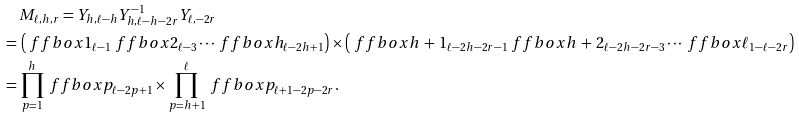<formula> <loc_0><loc_0><loc_500><loc_500>& M _ { \ell , h , r } = Y _ { h , \ell - h } Y _ { h , \ell - h - 2 r } ^ { - 1 } Y _ { \ell , - 2 r } \\ = \, & \left ( \ f f b o x { 1 } _ { \ell - 1 } \ f f b o x { 2 } _ { \ell - 3 } \cdots \ f f b o x { h } _ { \ell - 2 h + 1 } \right ) \times \left ( \ f f b o x { h \, + \, 1 } _ { \ell - 2 h - 2 r - 1 } \ f f b o x { h \, + \, 2 } _ { \ell - 2 h - 2 r - 3 } \cdots \ f f b o x { \ell } _ { 1 - \ell - 2 r } \right ) \\ = \, & \prod _ { p = 1 } ^ { h } \ f f b o x { p } _ { \ell - 2 p + 1 } \times \prod _ { p = h + 1 } ^ { \ell } \ f f b o x { p } _ { \ell + 1 - 2 p - 2 r } .</formula> 